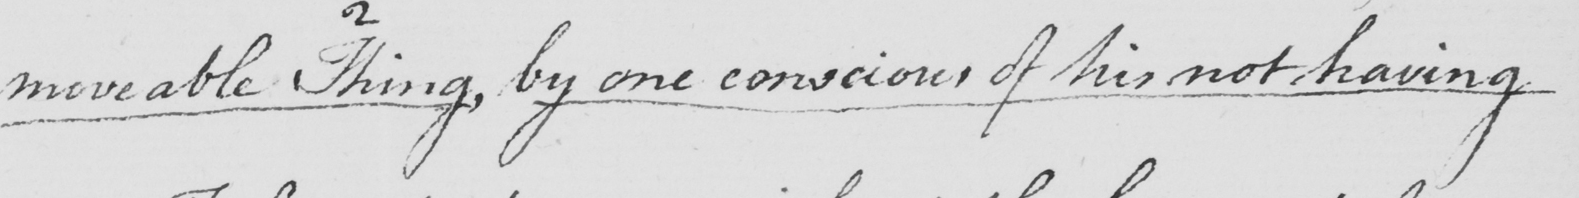What is written in this line of handwriting? moveable thing , by one conscious of his not having 